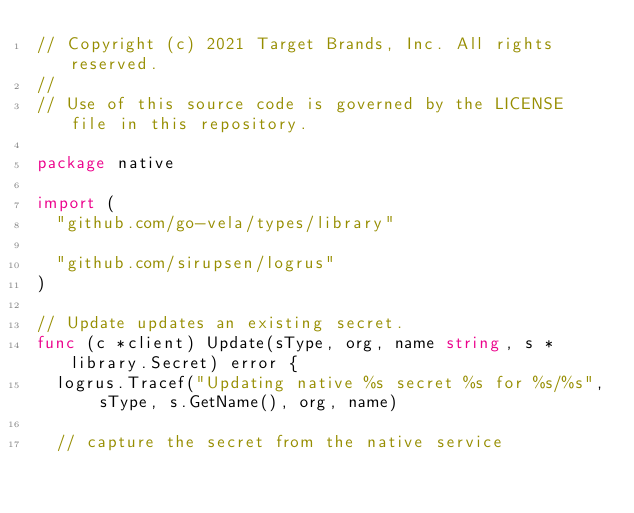Convert code to text. <code><loc_0><loc_0><loc_500><loc_500><_Go_>// Copyright (c) 2021 Target Brands, Inc. All rights reserved.
//
// Use of this source code is governed by the LICENSE file in this repository.

package native

import (
	"github.com/go-vela/types/library"

	"github.com/sirupsen/logrus"
)

// Update updates an existing secret.
func (c *client) Update(sType, org, name string, s *library.Secret) error {
	logrus.Tracef("Updating native %s secret %s for %s/%s", sType, s.GetName(), org, name)

	// capture the secret from the native service</code> 